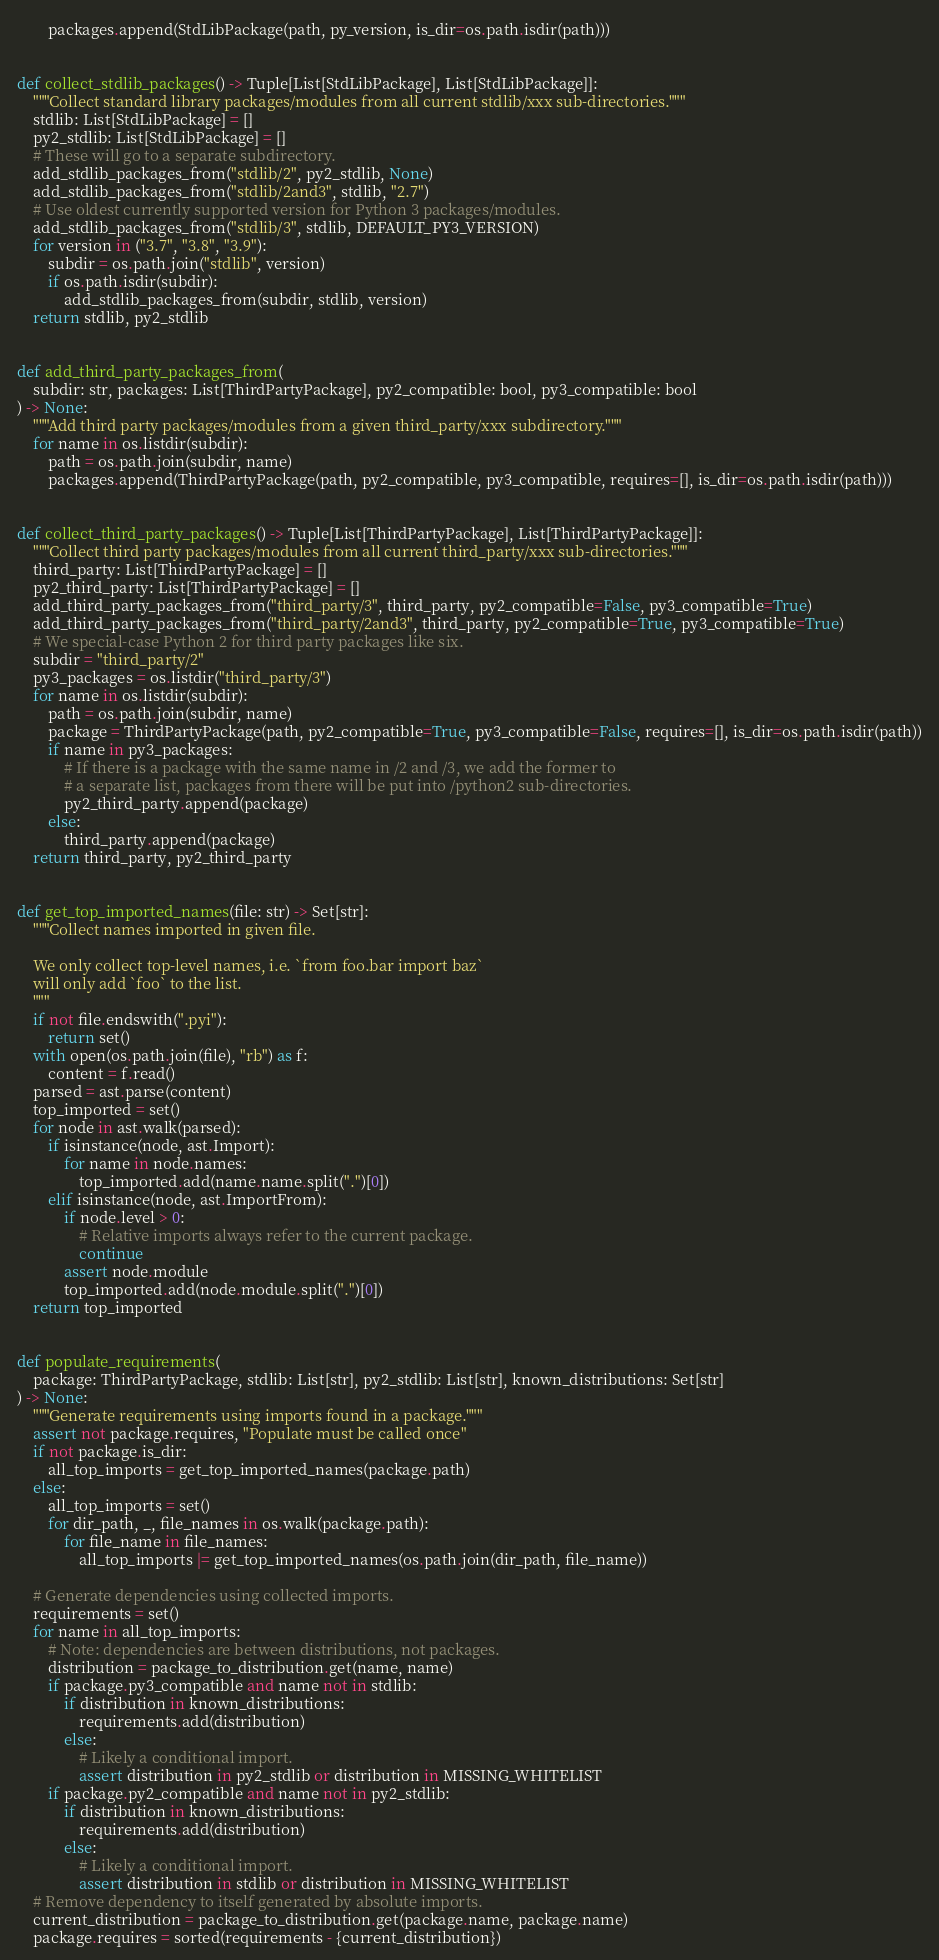Convert code to text. <code><loc_0><loc_0><loc_500><loc_500><_Python_>        packages.append(StdLibPackage(path, py_version, is_dir=os.path.isdir(path)))


def collect_stdlib_packages() -> Tuple[List[StdLibPackage], List[StdLibPackage]]:
    """Collect standard library packages/modules from all current stdlib/xxx sub-directories."""
    stdlib: List[StdLibPackage] = []
    py2_stdlib: List[StdLibPackage] = []
    # These will go to a separate subdirectory.
    add_stdlib_packages_from("stdlib/2", py2_stdlib, None)
    add_stdlib_packages_from("stdlib/2and3", stdlib, "2.7")
    # Use oldest currently supported version for Python 3 packages/modules.
    add_stdlib_packages_from("stdlib/3", stdlib, DEFAULT_PY3_VERSION)
    for version in ("3.7", "3.8", "3.9"):
        subdir = os.path.join("stdlib", version)
        if os.path.isdir(subdir):
            add_stdlib_packages_from(subdir, stdlib, version)
    return stdlib, py2_stdlib


def add_third_party_packages_from(
    subdir: str, packages: List[ThirdPartyPackage], py2_compatible: bool, py3_compatible: bool
) -> None:
    """Add third party packages/modules from a given third_party/xxx subdirectory."""
    for name in os.listdir(subdir):
        path = os.path.join(subdir, name)
        packages.append(ThirdPartyPackage(path, py2_compatible, py3_compatible, requires=[], is_dir=os.path.isdir(path)))


def collect_third_party_packages() -> Tuple[List[ThirdPartyPackage], List[ThirdPartyPackage]]:
    """Collect third party packages/modules from all current third_party/xxx sub-directories."""
    third_party: List[ThirdPartyPackage] = []
    py2_third_party: List[ThirdPartyPackage] = []
    add_third_party_packages_from("third_party/3", third_party, py2_compatible=False, py3_compatible=True)
    add_third_party_packages_from("third_party/2and3", third_party, py2_compatible=True, py3_compatible=True)
    # We special-case Python 2 for third party packages like six.
    subdir = "third_party/2"
    py3_packages = os.listdir("third_party/3")
    for name in os.listdir(subdir):
        path = os.path.join(subdir, name)
        package = ThirdPartyPackage(path, py2_compatible=True, py3_compatible=False, requires=[], is_dir=os.path.isdir(path))
        if name in py3_packages:
            # If there is a package with the same name in /2 and /3, we add the former to
            # a separate list, packages from there will be put into /python2 sub-directories.
            py2_third_party.append(package)
        else:
            third_party.append(package)
    return third_party, py2_third_party


def get_top_imported_names(file: str) -> Set[str]:
    """Collect names imported in given file.

    We only collect top-level names, i.e. `from foo.bar import baz`
    will only add `foo` to the list.
    """
    if not file.endswith(".pyi"):
        return set()
    with open(os.path.join(file), "rb") as f:
        content = f.read()
    parsed = ast.parse(content)
    top_imported = set()
    for node in ast.walk(parsed):
        if isinstance(node, ast.Import):
            for name in node.names:
                top_imported.add(name.name.split(".")[0])
        elif isinstance(node, ast.ImportFrom):
            if node.level > 0:
                # Relative imports always refer to the current package.
                continue
            assert node.module
            top_imported.add(node.module.split(".")[0])
    return top_imported


def populate_requirements(
    package: ThirdPartyPackage, stdlib: List[str], py2_stdlib: List[str], known_distributions: Set[str]
) -> None:
    """Generate requirements using imports found in a package."""
    assert not package.requires, "Populate must be called once"
    if not package.is_dir:
        all_top_imports = get_top_imported_names(package.path)
    else:
        all_top_imports = set()
        for dir_path, _, file_names in os.walk(package.path):
            for file_name in file_names:
                all_top_imports |= get_top_imported_names(os.path.join(dir_path, file_name))

    # Generate dependencies using collected imports.
    requirements = set()
    for name in all_top_imports:
        # Note: dependencies are between distributions, not packages.
        distribution = package_to_distribution.get(name, name)
        if package.py3_compatible and name not in stdlib:
            if distribution in known_distributions:
                requirements.add(distribution)
            else:
                # Likely a conditional import.
                assert distribution in py2_stdlib or distribution in MISSING_WHITELIST
        if package.py2_compatible and name not in py2_stdlib:
            if distribution in known_distributions:
                requirements.add(distribution)
            else:
                # Likely a conditional import.
                assert distribution in stdlib or distribution in MISSING_WHITELIST
    # Remove dependency to itself generated by absolute imports.
    current_distribution = package_to_distribution.get(package.name, package.name)
    package.requires = sorted(requirements - {current_distribution})

</code> 